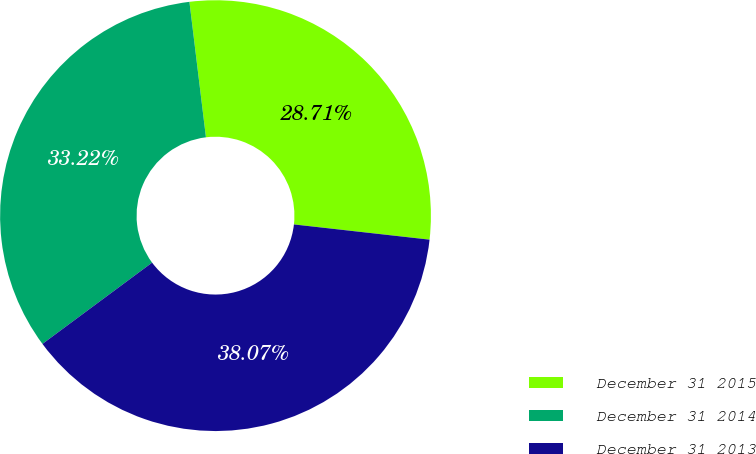Convert chart. <chart><loc_0><loc_0><loc_500><loc_500><pie_chart><fcel>December 31 2015<fcel>December 31 2014<fcel>December 31 2013<nl><fcel>28.71%<fcel>33.22%<fcel>38.07%<nl></chart> 